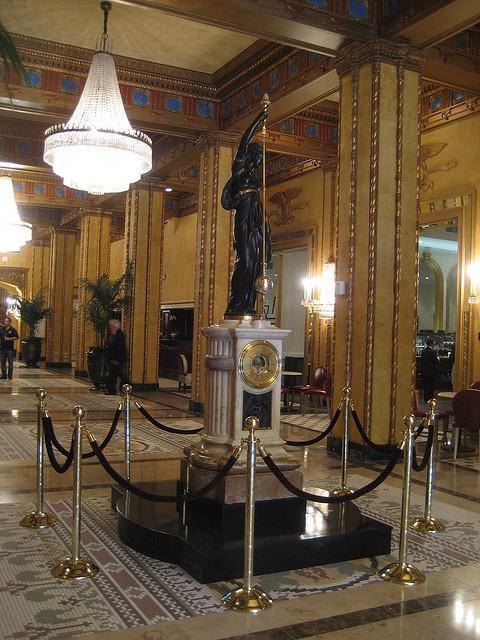Why is there a rope around this statue?
Make your selection from the four choices given to correctly answer the question.
Options: Prevent damage, law, style, religious reasons. Prevent damage. 